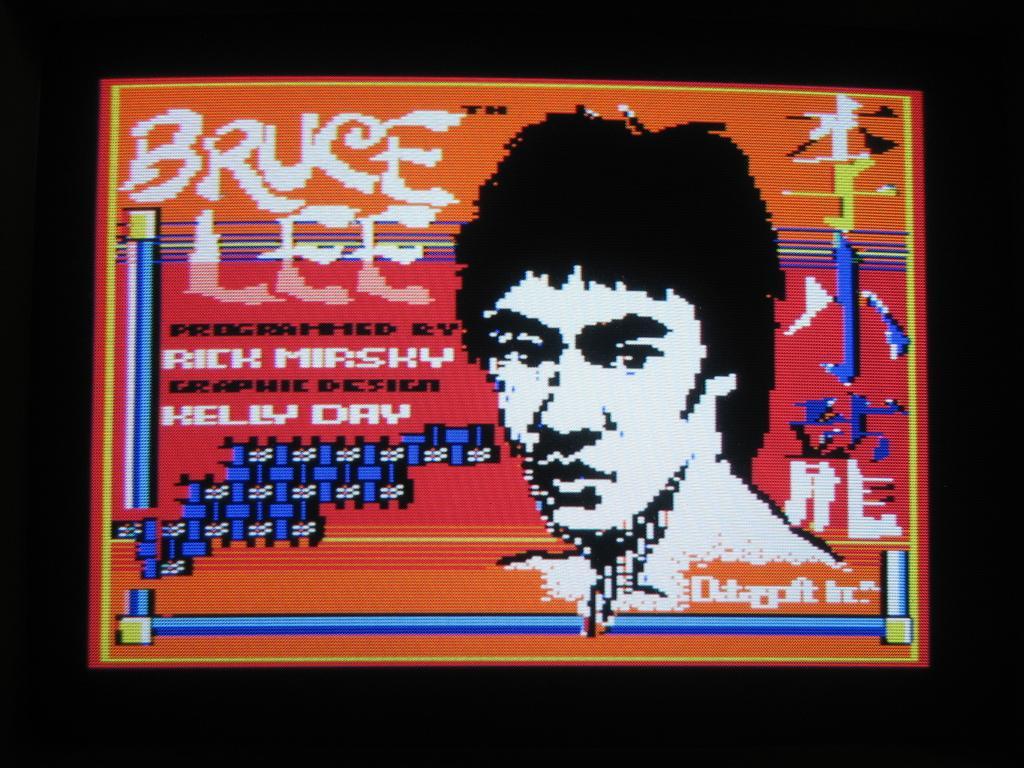Describe this image in one or two sentences. The picture is looking like an animated poster. In this picture we can see text and a person's face. 